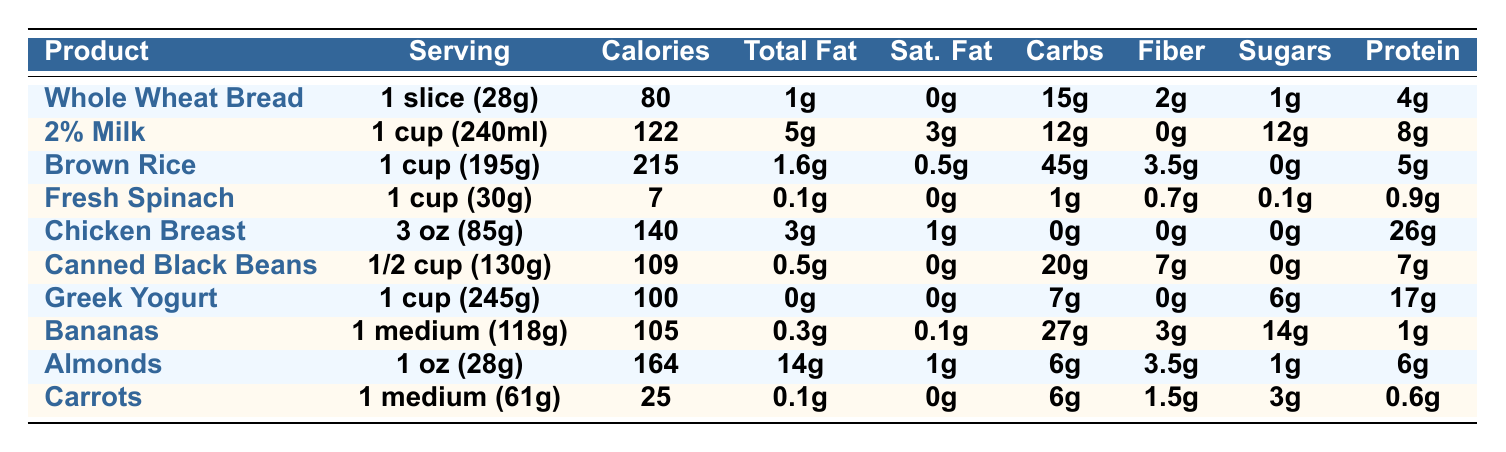What is the serving size of Greek Yogurt? The table lists the serving size for Greek Yogurt as "1 cup (245g)".
Answer: 1 cup (245g) How many calories are in Whole Wheat Bread? According to the table, Whole Wheat Bread has 80 calories.
Answer: 80 Which product has the highest protein content per serving? By reviewing the protein values, Chicken Breast has 26g of protein, which is the highest among all products.
Answer: Chicken Breast What is the total fat content in Canned Black Beans? The table indicates that Canned Black Beans have a total fat content of 0.5g.
Answer: 0.5g How many grams of carbohydrates does a medium Banana have? From the table, a medium Banana contains 27g of carbohydrates.
Answer: 27g Is the total fat in Fresh Spinach less than 0.2g? The table shows that Fresh Spinach has 0.1g of total fat, which is indeed less than 0.2g.
Answer: Yes What is the sum of the calories in 2% Milk and Greek Yogurt? The calories in 2% Milk (122) plus Greek Yogurt (100) total to 222 calories.
Answer: 222 Which has more calories, a cup of Brown Rice or a serving of Chicken Breast? Brown Rice has 215 calories, while Chicken Breast has 140 calories, so Brown Rice has more calories.
Answer: Brown Rice What is the difference in sugar content between Almonds and Bananas? Almonds have 1g of sugars and Bananas have 14g, so the difference is 14g - 1g = 13g.
Answer: 13g If you consume one serving each of Whole Wheat Bread, Canned Black Beans, and Fresh Spinach, what is the total calorie intake? Total calories: 80 (Whole Wheat Bread) + 109 (Canned Black Beans) + 7 (Fresh Spinach) = 196 calories.
Answer: 196 How much fiber does Chicken Breast provide compared to Fresh Spinach? Chicken Breast provides 0g of fiber while Fresh Spinach provides 0.7g, meaning Fresh Spinach provides more fiber.
Answer: Fresh Spinach provides more fiber Is it true that Greek Yogurt has more total fat than Whole Wheat Bread? Greek Yogurt contains 0g of total fat, while Whole Wheat Bread contains 1g. Therefore, this statement is false.
Answer: No What is the average protein content of the products listed? The total protein amounts to 4 + 8 + 5 + 0.9 + 26 + 7 + 17 + 1 + 6 + 0.6 = 75.5g. Dividing by 10 products gives an average of 7.55g.
Answer: 7.55g Which product is highest in sugars? Bananas have the highest sugar content at 14g, as shown in the table.
Answer: Bananas What is the protein content in a serving size of Fresh Spinach? Fresh Spinach has a protein content of 0.9g, as per the table.
Answer: 0.9g 